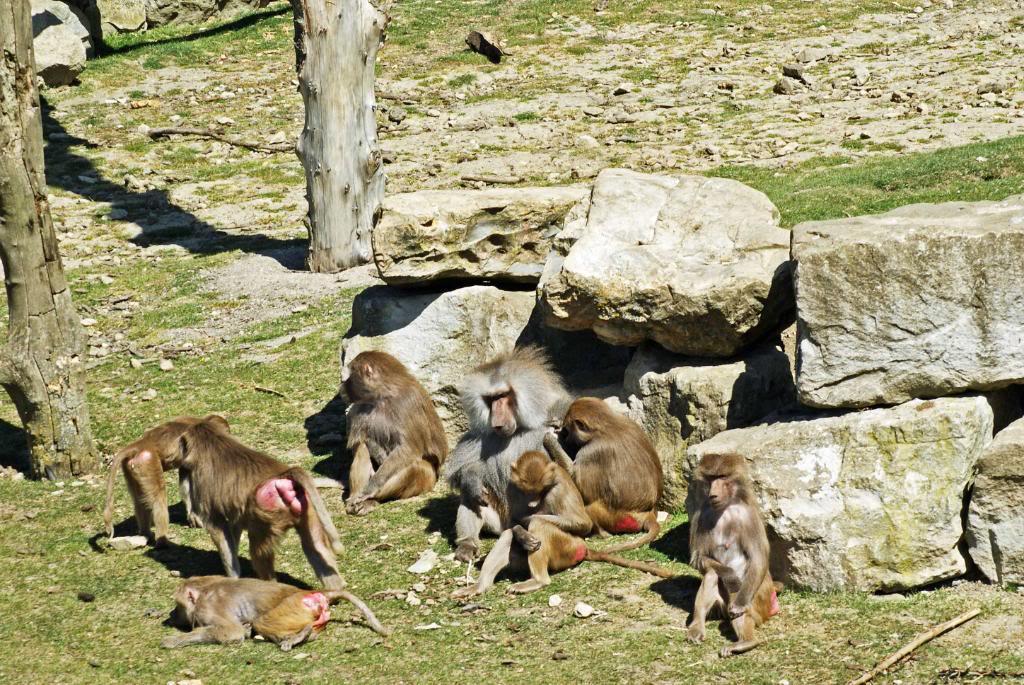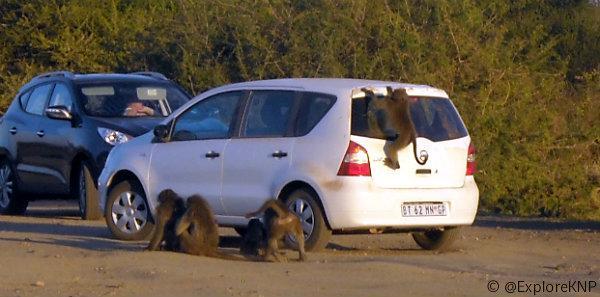The first image is the image on the left, the second image is the image on the right. Considering the images on both sides, is "In one image monkeys are interacting with a white vehicle with the doors open." valid? Answer yes or no. No. The first image is the image on the left, the second image is the image on the right. Considering the images on both sides, is "Several monkeys are sitting on top of a vehicle." valid? Answer yes or no. No. 